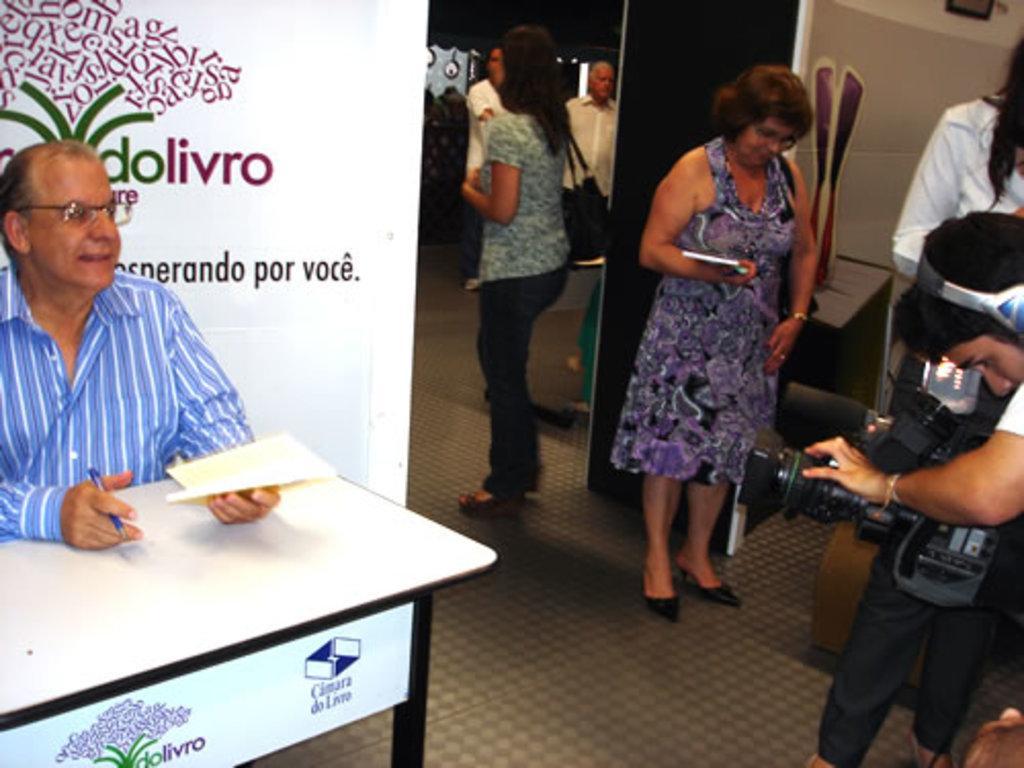How would you summarize this image in a sentence or two? In this image I can see number of people are standing here and a man is sitting. Here I can see a man is holding a camera. 